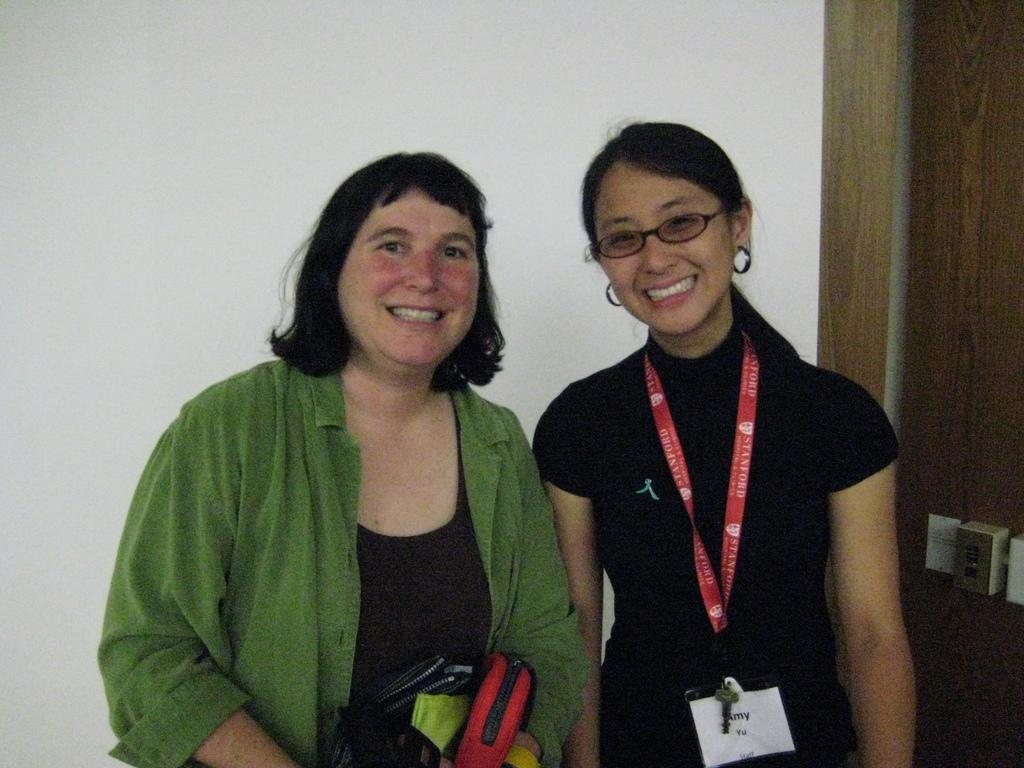How many people are in the image? There are two ladies in the center of the image. What can be seen in the background of the image? There is a wall in the background of the image. What type of whip is being used by one of the ladies in the image? There is no whip present in the image; the ladies are not using any whips. 